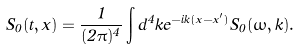Convert formula to latex. <formula><loc_0><loc_0><loc_500><loc_500>S _ { 0 } ( t , { x } ) = \frac { 1 } { ( 2 \pi ) ^ { 4 } } \int d ^ { 4 } k e ^ { - i k ( x - x ^ { \prime } ) } S _ { 0 } ( \omega , { k } ) .</formula> 